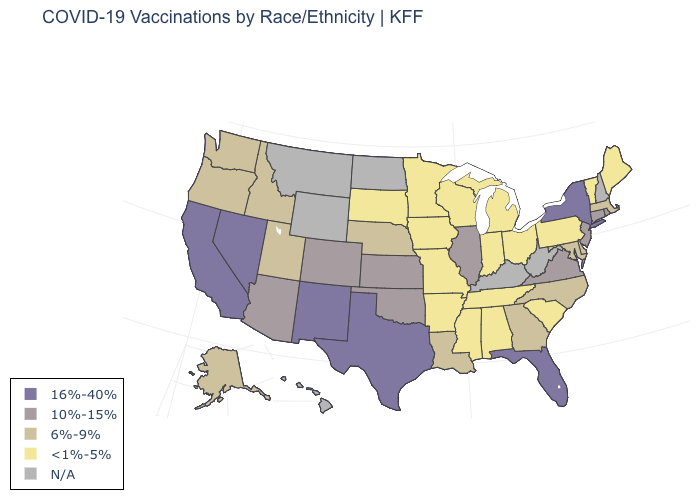Name the states that have a value in the range 6%-9%?
Short answer required. Alaska, Delaware, Georgia, Idaho, Louisiana, Maryland, Massachusetts, Nebraska, North Carolina, Oregon, Utah, Washington. What is the value of Arizona?
Give a very brief answer. 10%-15%. Name the states that have a value in the range 6%-9%?
Answer briefly. Alaska, Delaware, Georgia, Idaho, Louisiana, Maryland, Massachusetts, Nebraska, North Carolina, Oregon, Utah, Washington. Which states have the lowest value in the Northeast?
Quick response, please. Maine, Pennsylvania, Vermont. What is the lowest value in the USA?
Short answer required. <1%-5%. Name the states that have a value in the range <1%-5%?
Short answer required. Alabama, Arkansas, Indiana, Iowa, Maine, Michigan, Minnesota, Mississippi, Missouri, Ohio, Pennsylvania, South Carolina, South Dakota, Tennessee, Vermont, Wisconsin. Among the states that border Montana , which have the lowest value?
Be succinct. South Dakota. Name the states that have a value in the range 6%-9%?
Short answer required. Alaska, Delaware, Georgia, Idaho, Louisiana, Maryland, Massachusetts, Nebraska, North Carolina, Oregon, Utah, Washington. What is the value of New York?
Answer briefly. 16%-40%. Does the map have missing data?
Quick response, please. Yes. Name the states that have a value in the range 6%-9%?
Quick response, please. Alaska, Delaware, Georgia, Idaho, Louisiana, Maryland, Massachusetts, Nebraska, North Carolina, Oregon, Utah, Washington. What is the highest value in the USA?
Be succinct. 16%-40%. What is the value of Wisconsin?
Quick response, please. <1%-5%. What is the highest value in the West ?
Write a very short answer. 16%-40%. What is the value of Rhode Island?
Be succinct. 10%-15%. 